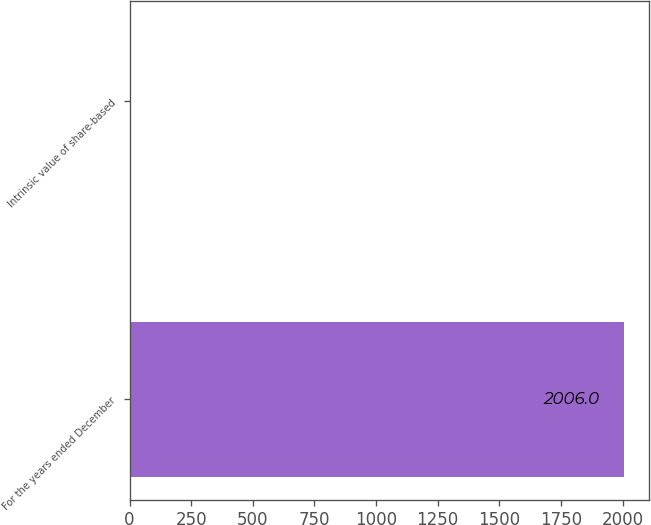Convert chart. <chart><loc_0><loc_0><loc_500><loc_500><bar_chart><fcel>For the years ended December<fcel>Intrinsic value of share-based<nl><fcel>2006<fcel>4.7<nl></chart> 